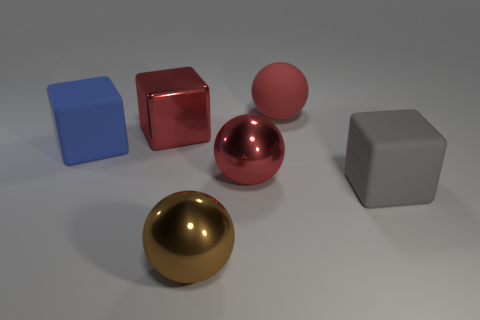There is a shiny object that is behind the red sphere that is to the left of the red sphere behind the large metal cube; what is its color?
Provide a succinct answer. Red. Do the sphere behind the big blue rubber block and the big blue object have the same material?
Your answer should be compact. Yes. Are there any other spheres of the same color as the big matte sphere?
Offer a very short reply. Yes. Are there any large gray matte cubes?
Provide a short and direct response. Yes. There is a red ball that is in front of the red metal cube; is it the same size as the large blue rubber thing?
Keep it short and to the point. Yes. Are there fewer big brown shiny things than large metal objects?
Your response must be concise. Yes. What shape is the big rubber object that is on the left side of the metal thing that is on the left side of the brown object that is on the left side of the gray object?
Offer a terse response. Cube. Are there any red cubes made of the same material as the large blue cube?
Provide a succinct answer. No. There is a shiny ball that is behind the large brown shiny object; is it the same color as the big matte cube on the right side of the brown metallic thing?
Keep it short and to the point. No. Are there fewer big red spheres behind the blue rubber thing than red spheres?
Make the answer very short. Yes. 